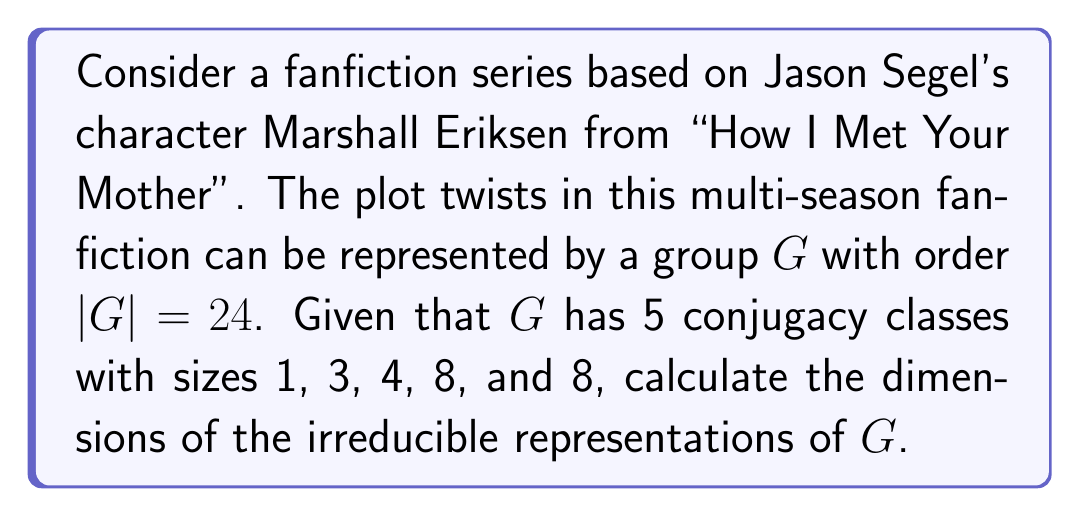Solve this math problem. To find the dimensions of the irreducible representations, we'll follow these steps:

1) Recall that the number of irreducible representations is equal to the number of conjugacy classes. Here, we have 5 conjugacy classes, so there are 5 irreducible representations.

2) Let the dimensions of these representations be $d_1, d_2, d_3, d_4,$ and $d_5$.

3) We know that the sum of the squares of the dimensions of irreducible representations is equal to the order of the group. This gives us our first equation:

   $$d_1^2 + d_2^2 + d_3^2 + d_4^2 + d_5^2 = 24$$

4) We also know that the trivial representation always exists and has dimension 1, so $d_1 = 1$.

5) The number of conjugacy classes of size 1 is equal to the number of one-dimensional representations. We have only one conjugacy class of size 1, so $d_2, d_3, d_4,$ and $d_5$ must be greater than 1.

6) Given the sizes of the conjugacy classes and the fact that the sum of the squares of the sizes of the conjugacy classes equals $|G|^2$, we have:

   $$1^2 + 3^2 + 4^2 + 8^2 + 8^2 = 24^2 = 576$$

7) Now, we can use the fact that the sum of the squares of the dimensions must equal 24, and they must all be integers. The only possibility that satisfies these conditions is:

   $$1^2 + 1^2 + 2^2 + 2^2 + 3^2 = 24$$

Therefore, the dimensions of the irreducible representations are 1, 1, 2, 2, and 3.
Answer: 1, 1, 2, 2, 3 